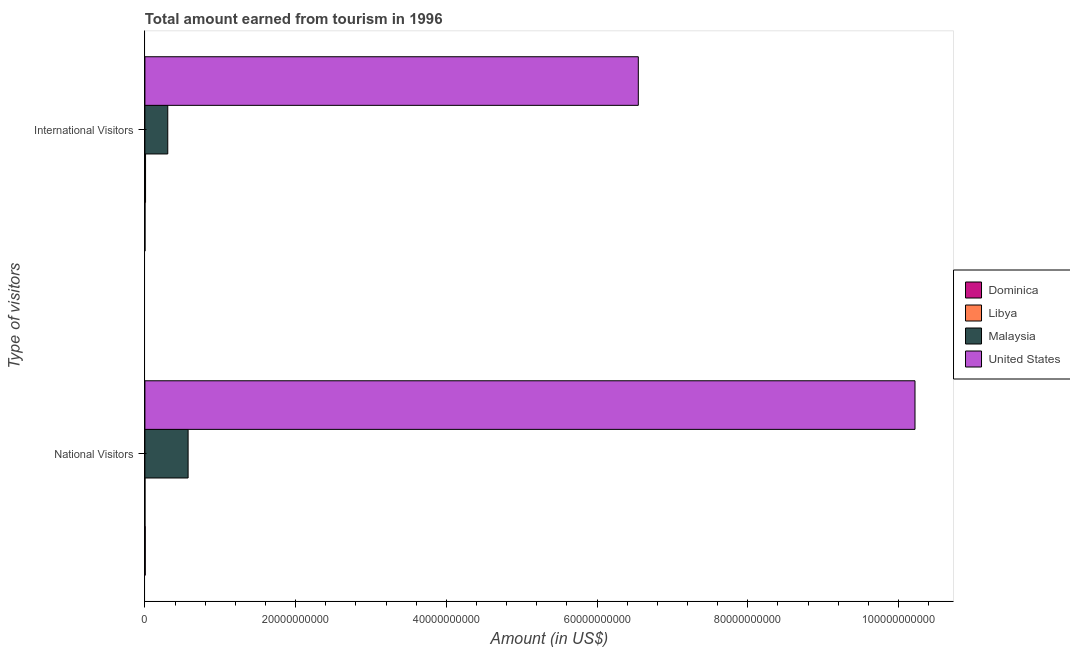How many different coloured bars are there?
Your response must be concise. 4. How many groups of bars are there?
Give a very brief answer. 2. Are the number of bars per tick equal to the number of legend labels?
Give a very brief answer. Yes. Are the number of bars on each tick of the Y-axis equal?
Provide a short and direct response. Yes. What is the label of the 2nd group of bars from the top?
Keep it short and to the point. National Visitors. What is the amount earned from international visitors in Libya?
Give a very brief answer. 8.50e+07. Across all countries, what is the maximum amount earned from national visitors?
Provide a succinct answer. 1.02e+11. Across all countries, what is the minimum amount earned from national visitors?
Your answer should be compact. 4.00e+06. In which country was the amount earned from national visitors maximum?
Provide a short and direct response. United States. In which country was the amount earned from national visitors minimum?
Offer a terse response. Libya. What is the total amount earned from international visitors in the graph?
Provide a succinct answer. 6.86e+1. What is the difference between the amount earned from national visitors in Libya and that in Malaysia?
Ensure brevity in your answer.  -5.73e+09. What is the difference between the amount earned from international visitors in Malaysia and the amount earned from national visitors in United States?
Give a very brief answer. -9.92e+1. What is the average amount earned from international visitors per country?
Your response must be concise. 1.72e+1. What is the difference between the amount earned from international visitors and amount earned from national visitors in Malaysia?
Your answer should be compact. -2.70e+09. What is the ratio of the amount earned from international visitors in Dominica to that in Libya?
Make the answer very short. 0.08. Is the amount earned from international visitors in Malaysia less than that in Dominica?
Provide a short and direct response. No. What does the 2nd bar from the top in National Visitors represents?
Give a very brief answer. Malaysia. What does the 4th bar from the bottom in International Visitors represents?
Keep it short and to the point. United States. How many bars are there?
Keep it short and to the point. 8. Are all the bars in the graph horizontal?
Make the answer very short. Yes. How many countries are there in the graph?
Ensure brevity in your answer.  4. Are the values on the major ticks of X-axis written in scientific E-notation?
Ensure brevity in your answer.  No. How many legend labels are there?
Make the answer very short. 4. What is the title of the graph?
Your answer should be compact. Total amount earned from tourism in 1996. What is the label or title of the X-axis?
Provide a succinct answer. Amount (in US$). What is the label or title of the Y-axis?
Ensure brevity in your answer.  Type of visitors. What is the Amount (in US$) in Dominica in National Visitors?
Your answer should be very brief. 4.40e+07. What is the Amount (in US$) in Malaysia in National Visitors?
Your answer should be very brief. 5.73e+09. What is the Amount (in US$) of United States in National Visitors?
Offer a terse response. 1.02e+11. What is the Amount (in US$) of Libya in International Visitors?
Provide a succinct answer. 8.50e+07. What is the Amount (in US$) in Malaysia in International Visitors?
Your response must be concise. 3.03e+09. What is the Amount (in US$) in United States in International Visitors?
Your answer should be very brief. 6.55e+1. Across all Type of visitors, what is the maximum Amount (in US$) of Dominica?
Offer a terse response. 4.40e+07. Across all Type of visitors, what is the maximum Amount (in US$) in Libya?
Provide a succinct answer. 8.50e+07. Across all Type of visitors, what is the maximum Amount (in US$) in Malaysia?
Ensure brevity in your answer.  5.73e+09. Across all Type of visitors, what is the maximum Amount (in US$) of United States?
Ensure brevity in your answer.  1.02e+11. Across all Type of visitors, what is the minimum Amount (in US$) of Dominica?
Provide a succinct answer. 7.00e+06. Across all Type of visitors, what is the minimum Amount (in US$) in Libya?
Give a very brief answer. 4.00e+06. Across all Type of visitors, what is the minimum Amount (in US$) in Malaysia?
Your response must be concise. 3.03e+09. Across all Type of visitors, what is the minimum Amount (in US$) in United States?
Offer a very short reply. 6.55e+1. What is the total Amount (in US$) of Dominica in the graph?
Your response must be concise. 5.10e+07. What is the total Amount (in US$) of Libya in the graph?
Offer a terse response. 8.90e+07. What is the total Amount (in US$) in Malaysia in the graph?
Offer a very short reply. 8.76e+09. What is the total Amount (in US$) in United States in the graph?
Provide a succinct answer. 1.68e+11. What is the difference between the Amount (in US$) in Dominica in National Visitors and that in International Visitors?
Offer a very short reply. 3.70e+07. What is the difference between the Amount (in US$) in Libya in National Visitors and that in International Visitors?
Offer a very short reply. -8.10e+07. What is the difference between the Amount (in US$) in Malaysia in National Visitors and that in International Visitors?
Keep it short and to the point. 2.70e+09. What is the difference between the Amount (in US$) in United States in National Visitors and that in International Visitors?
Your answer should be compact. 3.67e+1. What is the difference between the Amount (in US$) in Dominica in National Visitors and the Amount (in US$) in Libya in International Visitors?
Provide a succinct answer. -4.10e+07. What is the difference between the Amount (in US$) in Dominica in National Visitors and the Amount (in US$) in Malaysia in International Visitors?
Your answer should be very brief. -2.99e+09. What is the difference between the Amount (in US$) of Dominica in National Visitors and the Amount (in US$) of United States in International Visitors?
Give a very brief answer. -6.54e+1. What is the difference between the Amount (in US$) in Libya in National Visitors and the Amount (in US$) in Malaysia in International Visitors?
Your answer should be very brief. -3.03e+09. What is the difference between the Amount (in US$) in Libya in National Visitors and the Amount (in US$) in United States in International Visitors?
Give a very brief answer. -6.55e+1. What is the difference between the Amount (in US$) in Malaysia in National Visitors and the Amount (in US$) in United States in International Visitors?
Your answer should be very brief. -5.97e+1. What is the average Amount (in US$) in Dominica per Type of visitors?
Your answer should be compact. 2.55e+07. What is the average Amount (in US$) of Libya per Type of visitors?
Your response must be concise. 4.45e+07. What is the average Amount (in US$) of Malaysia per Type of visitors?
Keep it short and to the point. 4.38e+09. What is the average Amount (in US$) of United States per Type of visitors?
Keep it short and to the point. 8.38e+1. What is the difference between the Amount (in US$) of Dominica and Amount (in US$) of Libya in National Visitors?
Keep it short and to the point. 4.00e+07. What is the difference between the Amount (in US$) of Dominica and Amount (in US$) of Malaysia in National Visitors?
Provide a succinct answer. -5.69e+09. What is the difference between the Amount (in US$) of Dominica and Amount (in US$) of United States in National Visitors?
Your answer should be compact. -1.02e+11. What is the difference between the Amount (in US$) in Libya and Amount (in US$) in Malaysia in National Visitors?
Provide a succinct answer. -5.73e+09. What is the difference between the Amount (in US$) of Libya and Amount (in US$) of United States in National Visitors?
Your response must be concise. -1.02e+11. What is the difference between the Amount (in US$) of Malaysia and Amount (in US$) of United States in National Visitors?
Your response must be concise. -9.65e+1. What is the difference between the Amount (in US$) of Dominica and Amount (in US$) of Libya in International Visitors?
Your response must be concise. -7.80e+07. What is the difference between the Amount (in US$) in Dominica and Amount (in US$) in Malaysia in International Visitors?
Offer a very short reply. -3.02e+09. What is the difference between the Amount (in US$) of Dominica and Amount (in US$) of United States in International Visitors?
Make the answer very short. -6.55e+1. What is the difference between the Amount (in US$) of Libya and Amount (in US$) of Malaysia in International Visitors?
Offer a terse response. -2.95e+09. What is the difference between the Amount (in US$) in Libya and Amount (in US$) in United States in International Visitors?
Ensure brevity in your answer.  -6.54e+1. What is the difference between the Amount (in US$) in Malaysia and Amount (in US$) in United States in International Visitors?
Provide a short and direct response. -6.24e+1. What is the ratio of the Amount (in US$) in Dominica in National Visitors to that in International Visitors?
Offer a terse response. 6.29. What is the ratio of the Amount (in US$) of Libya in National Visitors to that in International Visitors?
Your response must be concise. 0.05. What is the ratio of the Amount (in US$) of Malaysia in National Visitors to that in International Visitors?
Provide a short and direct response. 1.89. What is the ratio of the Amount (in US$) of United States in National Visitors to that in International Visitors?
Offer a terse response. 1.56. What is the difference between the highest and the second highest Amount (in US$) in Dominica?
Offer a terse response. 3.70e+07. What is the difference between the highest and the second highest Amount (in US$) of Libya?
Offer a very short reply. 8.10e+07. What is the difference between the highest and the second highest Amount (in US$) in Malaysia?
Keep it short and to the point. 2.70e+09. What is the difference between the highest and the second highest Amount (in US$) of United States?
Make the answer very short. 3.67e+1. What is the difference between the highest and the lowest Amount (in US$) of Dominica?
Your response must be concise. 3.70e+07. What is the difference between the highest and the lowest Amount (in US$) in Libya?
Your response must be concise. 8.10e+07. What is the difference between the highest and the lowest Amount (in US$) of Malaysia?
Offer a terse response. 2.70e+09. What is the difference between the highest and the lowest Amount (in US$) of United States?
Make the answer very short. 3.67e+1. 